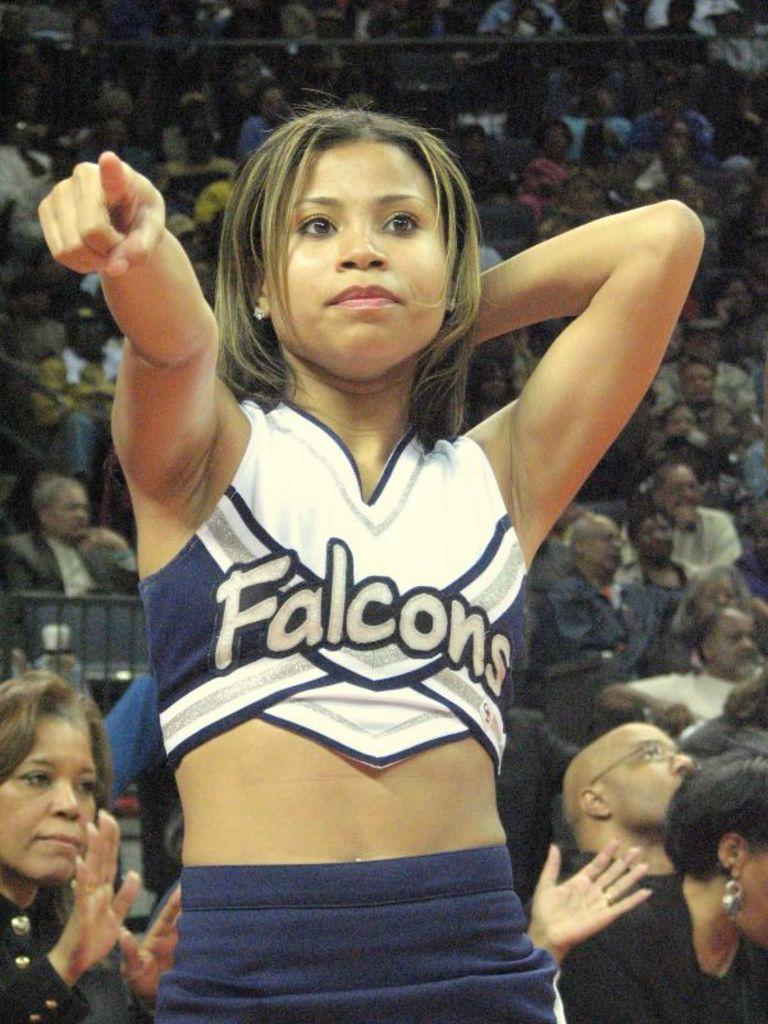<image>
Render a clear and concise summary of the photo. a girl that has a Falcons jersey on for cheering 